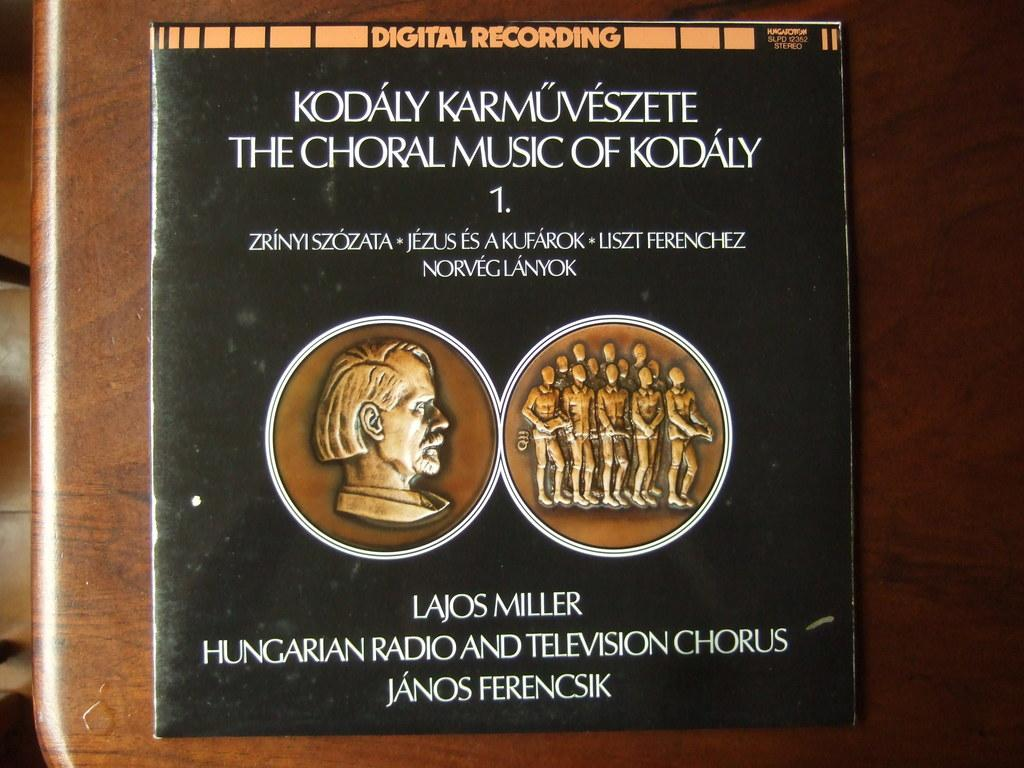<image>
Create a compact narrative representing the image presented. The cover for a digital recording about Hungarian choral music sits on wooden table. 